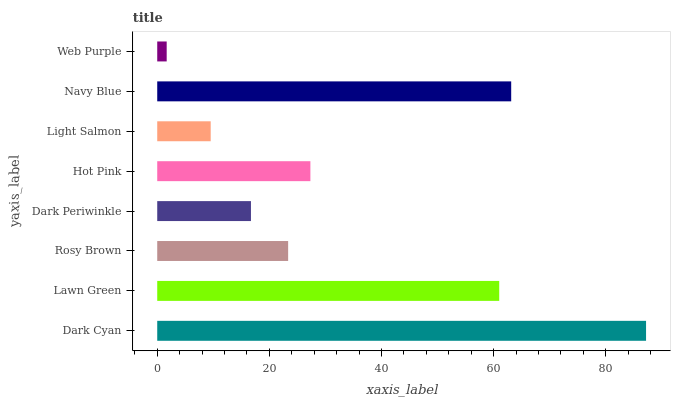Is Web Purple the minimum?
Answer yes or no. Yes. Is Dark Cyan the maximum?
Answer yes or no. Yes. Is Lawn Green the minimum?
Answer yes or no. No. Is Lawn Green the maximum?
Answer yes or no. No. Is Dark Cyan greater than Lawn Green?
Answer yes or no. Yes. Is Lawn Green less than Dark Cyan?
Answer yes or no. Yes. Is Lawn Green greater than Dark Cyan?
Answer yes or no. No. Is Dark Cyan less than Lawn Green?
Answer yes or no. No. Is Hot Pink the high median?
Answer yes or no. Yes. Is Rosy Brown the low median?
Answer yes or no. Yes. Is Rosy Brown the high median?
Answer yes or no. No. Is Hot Pink the low median?
Answer yes or no. No. 